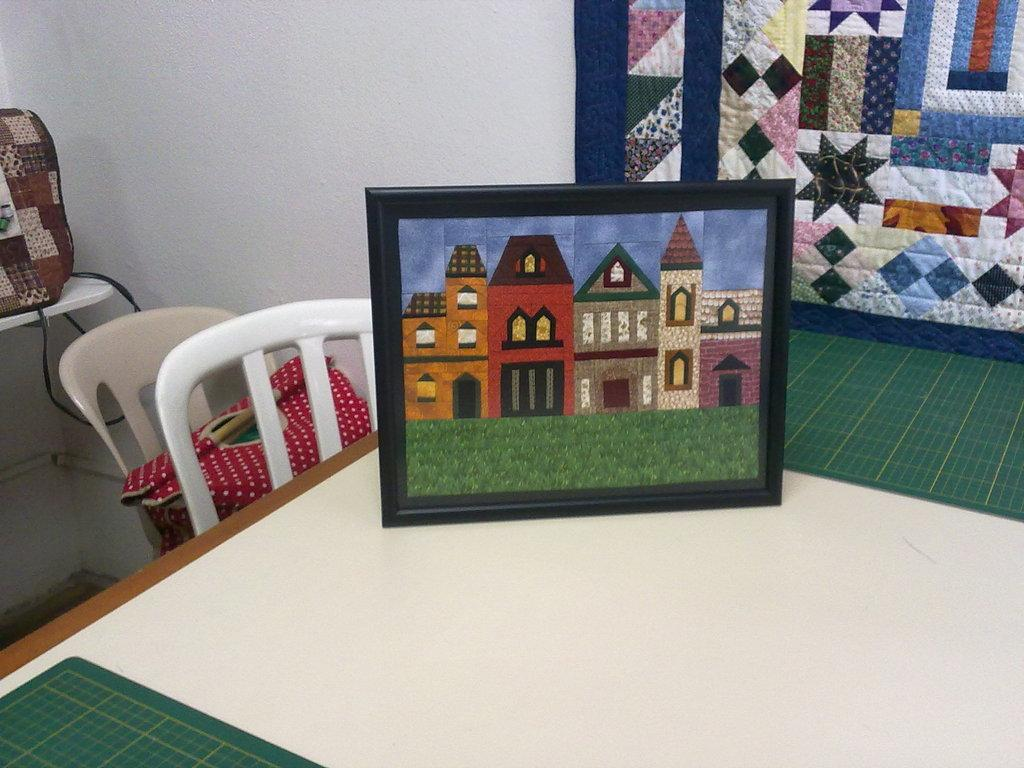What object is placed on the table in the image? There is a photo frame on the table. What can be seen in front of the chairs near the table? There are bags in front of the chairs. What is located beside the chair in the image? There is a wall beside the chair. What type of railway is visible in the image? There is no railway present in the image. What experience can be gained from observing the photo frame in the image? The image does not convey any specific experience related to the photo frame. 